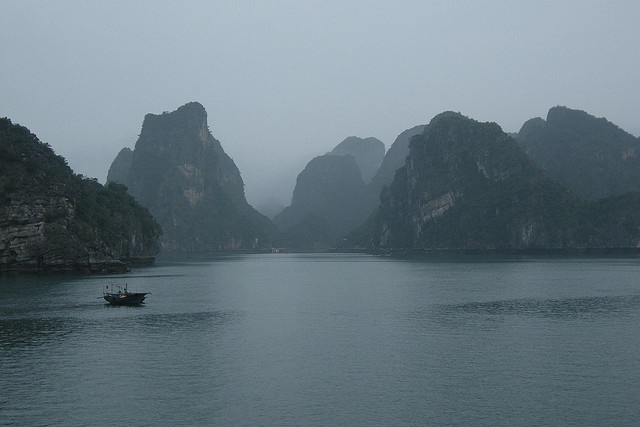Describe the objects in this image and their specific colors. I can see boat in darkgray, black, gray, darkblue, and purple tones and people in darkgray, black, gray, and darkblue tones in this image. 